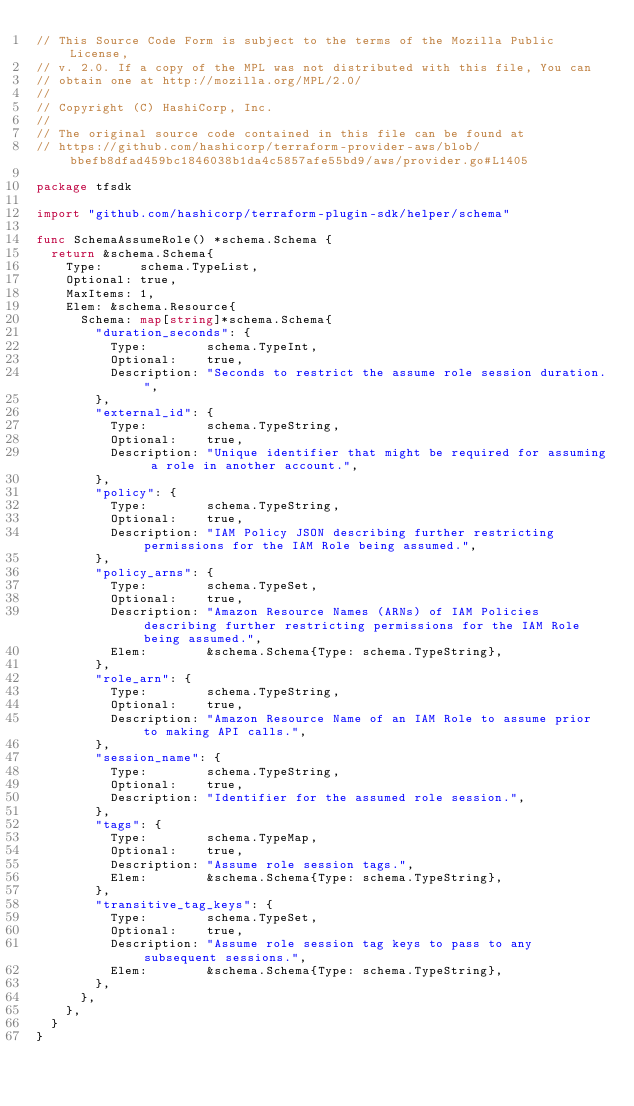<code> <loc_0><loc_0><loc_500><loc_500><_Go_>// This Source Code Form is subject to the terms of the Mozilla Public License,
// v. 2.0. If a copy of the MPL was not distributed with this file, You can
// obtain one at http://mozilla.org/MPL/2.0/
//
// Copyright (C) HashiCorp, Inc.
//
// The original source code contained in this file can be found at
// https://github.com/hashicorp/terraform-provider-aws/blob/bbefb8dfad459bc1846038b1da4c5857afe55bd9/aws/provider.go#L1405

package tfsdk

import "github.com/hashicorp/terraform-plugin-sdk/helper/schema"

func SchemaAssumeRole() *schema.Schema {
	return &schema.Schema{
		Type:     schema.TypeList,
		Optional: true,
		MaxItems: 1,
		Elem: &schema.Resource{
			Schema: map[string]*schema.Schema{
				"duration_seconds": {
					Type:        schema.TypeInt,
					Optional:    true,
					Description: "Seconds to restrict the assume role session duration.",
				},
				"external_id": {
					Type:        schema.TypeString,
					Optional:    true,
					Description: "Unique identifier that might be required for assuming a role in another account.",
				},
				"policy": {
					Type:        schema.TypeString,
					Optional:    true,
					Description: "IAM Policy JSON describing further restricting permissions for the IAM Role being assumed.",
				},
				"policy_arns": {
					Type:        schema.TypeSet,
					Optional:    true,
					Description: "Amazon Resource Names (ARNs) of IAM Policies describing further restricting permissions for the IAM Role being assumed.",
					Elem:        &schema.Schema{Type: schema.TypeString},
				},
				"role_arn": {
					Type:        schema.TypeString,
					Optional:    true,
					Description: "Amazon Resource Name of an IAM Role to assume prior to making API calls.",
				},
				"session_name": {
					Type:        schema.TypeString,
					Optional:    true,
					Description: "Identifier for the assumed role session.",
				},
				"tags": {
					Type:        schema.TypeMap,
					Optional:    true,
					Description: "Assume role session tags.",
					Elem:        &schema.Schema{Type: schema.TypeString},
				},
				"transitive_tag_keys": {
					Type:        schema.TypeSet,
					Optional:    true,
					Description: "Assume role session tag keys to pass to any subsequent sessions.",
					Elem:        &schema.Schema{Type: schema.TypeString},
				},
			},
		},
	}
}
</code> 